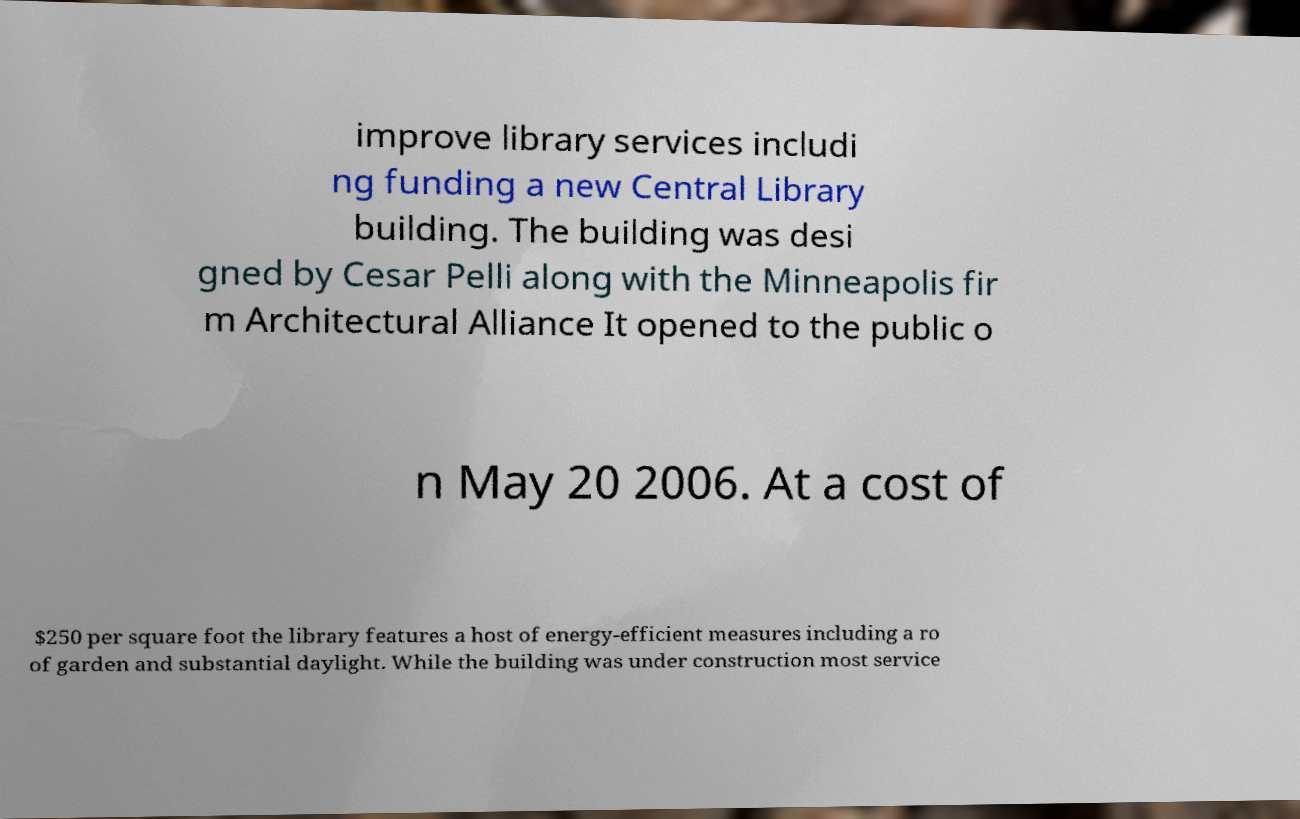Can you read and provide the text displayed in the image?This photo seems to have some interesting text. Can you extract and type it out for me? improve library services includi ng funding a new Central Library building. The building was desi gned by Cesar Pelli along with the Minneapolis fir m Architectural Alliance It opened to the public o n May 20 2006. At a cost of $250 per square foot the library features a host of energy-efficient measures including a ro of garden and substantial daylight. While the building was under construction most service 